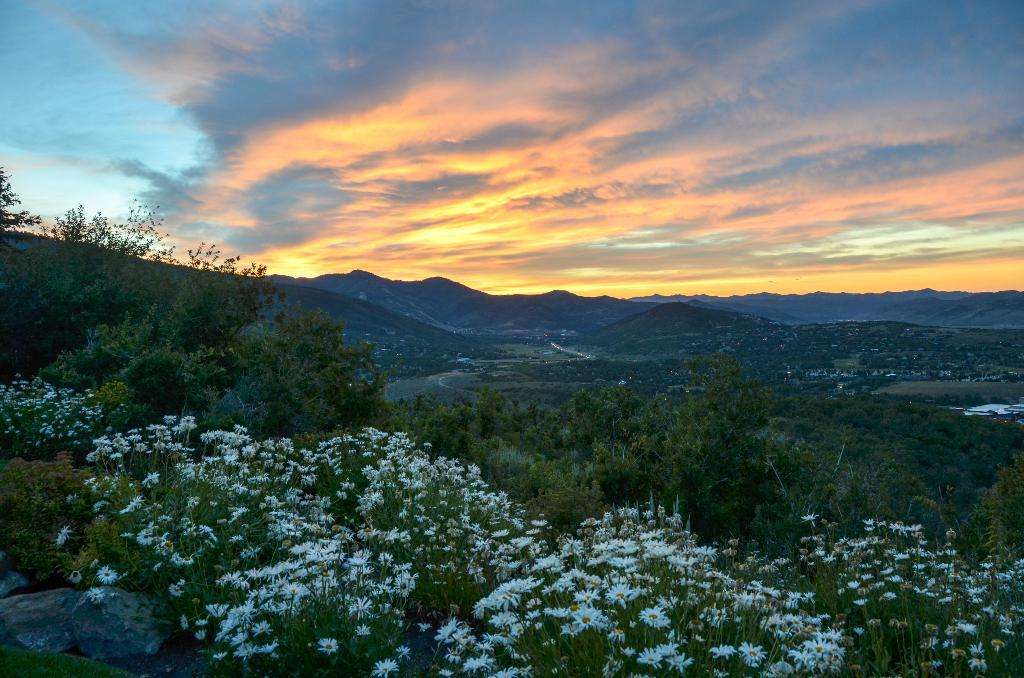What type of plants are at the bottom of the image? There are plants with flowers at the bottom of the image. What can be seen in the background of the image? There are trees, grass, houses, mountains, and clouds in the sky in the background of the image. What type of camp can be seen in the image? There is no camp present in the image. 